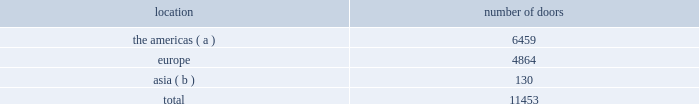Our wholesale segment our wholesale segment sells our products to leading upscale and certain mid-tier department stores , specialty stores , and golf and pro shops , both domestically and internationally .
We have continued to focus on elevating our brand by improving in- store product assortment and presentation , as well as full-price sell-throughs to consumers .
As of the end of fiscal 2014 , our ralph lauren-branded products were sold through over 11000 doors worldwide and we invested $ 53 million of capital in related shop- within-shops primarily in domestic and international department and specialty stores .
Our products are also sold through the e- commerce sites of certain of our wholesale customers .
The primary product offerings sold through our wholesale channels of distribution include menswear , womenswear , childrenswear , accessories , and home furnishings .
Our collection brands 2014 ralph lauren women's collection and black label and men's purple label and black label 2014 are distributed worldwide through a limited number of premier fashion retailers .
Department stores are our major wholesale customers in north america .
In latin america , our wholesale products are sold in department stores and specialty stores .
In europe , our wholesale sales are a varying mix of sales to both department stores and specialty stores , depending on the country .
In japan , our wholesale products are distributed primarily through shop-within-shops at premier and top-tier department stores , and the mix of business is weighted to men's and women's blue label .
In the greater china and southeast asia region and australia , our wholesale products are sold mainly at mid and top-tier department stores , and the mix of business is primarily weighted to men's and women's blue label .
We also distribute product to certain licensed stores operated by our partners in latin america , europe , and asia .
In addition , our club monaco products are distributed through select department stores and specialty stores in europe .
We sell the majority of our excess and out-of-season products through secondary distribution channels worldwide , including our retail factory stores .
Worldwide distribution channels the table presents the number of doors by geographic location in which ralph lauren-branded products distributed by our wholesale segment were sold to consumers in our primary channels of distribution as of march 29 , 2014: .
( a ) includes the u.s. , canada , and latin america .
( b ) includes australia , china , japan , the philippines , and thailand .
In addition , chaps-branded products distributed by our wholesale segment were sold domestically through approximately 2800 doors as of march 29 , 2014 .
We have three key wholesale customers that generate significant sales volume .
For fiscal 2014 , these customers in the aggregate accounted for approximately 50% ( 50 % ) of our total wholesale revenues , with macy's , inc .
( "macy's" ) representing approximately 25% ( 25 % ) of our total wholesale revenues .
Our products are sold primarily through our own sales forces .
Our wholesale segment maintains its primary showrooms in new york city .
In addition , we maintain regional showrooms in milan , paris , london , munich , madrid , stockholm , and panama .
Shop-within-shops .
As a critical element of our distribution to department stores , we and our licensing partners utilize shop-within-shops to enhance brand recognition , to permit more complete merchandising of our lines by the department stores , and to differentiate the presentation of our products .
As of march 29 , 2014 , we had approximately 22000 shop-within-shops in our primary channels of distribution dedicated to our ralph lauren-branded wholesale products worldwide .
The size of our shop-within-shops ranges from approximately 100 to 9200 square feet .
Shop-within-shop fixed assets primarily include items such as customized freestanding fixtures , wall cases .
What percentage of doors in the wholesale segment as of march 29 , 2014 where in the americas? 
Computations: (6459 / 11453)
Answer: 0.56396. 